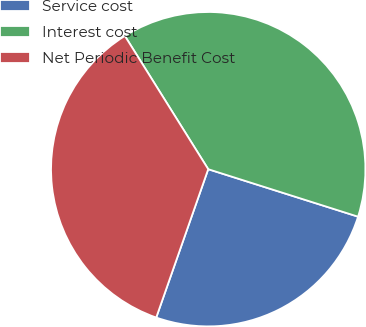<chart> <loc_0><loc_0><loc_500><loc_500><pie_chart><fcel>Service cost<fcel>Interest cost<fcel>Net Periodic Benefit Cost<nl><fcel>25.48%<fcel>38.78%<fcel>35.74%<nl></chart> 